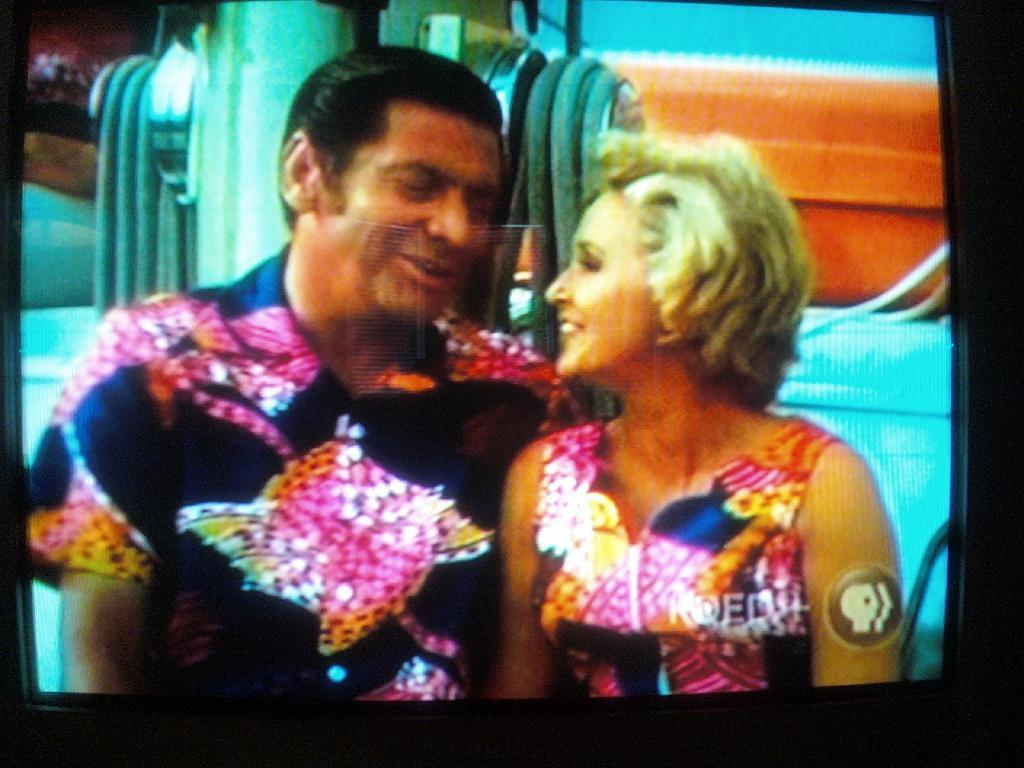How many people are in the image? There is a man and a woman in the image. Where are the man and woman located in the image? The man and woman are in the center of the image. What can be seen behind the man and woman? There appears to be a machine behind the man and woman. What type of oatmeal is being prepared by the man in the image? There is no oatmeal or any indication of food preparation in the image. What type of plough is being used by the man in the image? There is no plough or any agricultural equipment present in the image. 